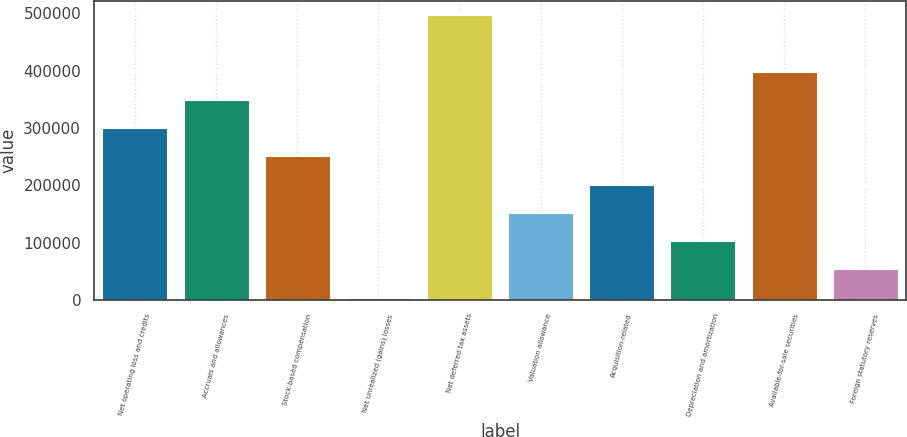Convert chart. <chart><loc_0><loc_0><loc_500><loc_500><bar_chart><fcel>Net operating loss and credits<fcel>Accruals and allowances<fcel>Stock-based compensation<fcel>Net unrealized (gains) losses<fcel>Net deferred tax assets<fcel>Valuation allowance<fcel>Acquisition-related<fcel>Depreciation and amortization<fcel>Available-for-sale securities<fcel>Foreign statutory reserves<nl><fcel>299736<fcel>349001<fcel>250471<fcel>4145<fcel>496797<fcel>151941<fcel>201206<fcel>102675<fcel>398267<fcel>53410.2<nl></chart> 